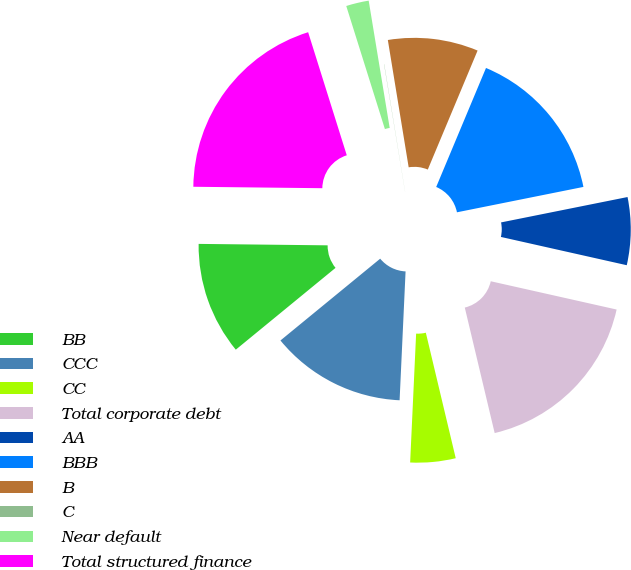Convert chart to OTSL. <chart><loc_0><loc_0><loc_500><loc_500><pie_chart><fcel>BB<fcel>CCC<fcel>CC<fcel>Total corporate debt<fcel>AA<fcel>BBB<fcel>B<fcel>C<fcel>Near default<fcel>Total structured finance<nl><fcel>11.11%<fcel>13.33%<fcel>4.46%<fcel>17.76%<fcel>6.67%<fcel>15.54%<fcel>8.89%<fcel>0.02%<fcel>2.24%<fcel>19.98%<nl></chart> 